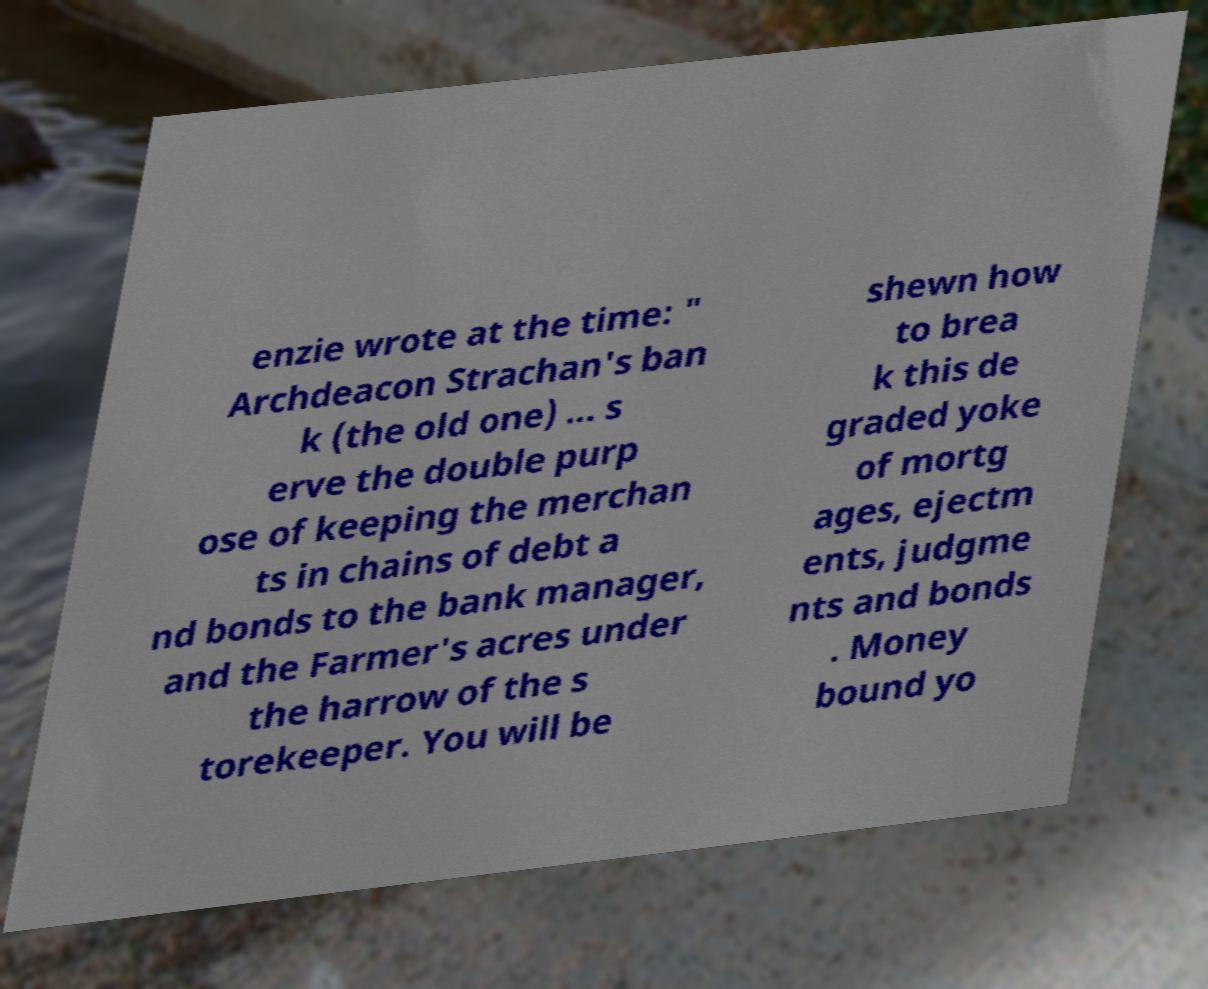For documentation purposes, I need the text within this image transcribed. Could you provide that? enzie wrote at the time: " Archdeacon Strachan's ban k (the old one) ... s erve the double purp ose of keeping the merchan ts in chains of debt a nd bonds to the bank manager, and the Farmer's acres under the harrow of the s torekeeper. You will be shewn how to brea k this de graded yoke of mortg ages, ejectm ents, judgme nts and bonds . Money bound yo 